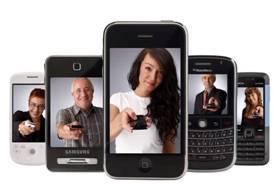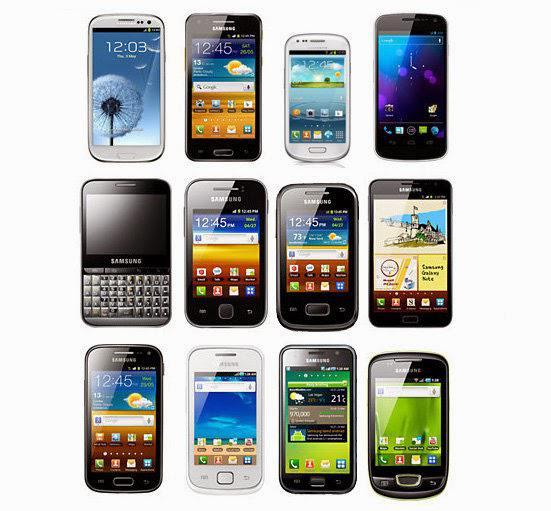The first image is the image on the left, the second image is the image on the right. Evaluate the accuracy of this statement regarding the images: "There is a single phone in the left image.". Is it true? Answer yes or no. No. The first image is the image on the left, the second image is the image on the right. Given the left and right images, does the statement "There is a single cell phone in the image on the left and at least twice as many on the right." hold true? Answer yes or no. No. 